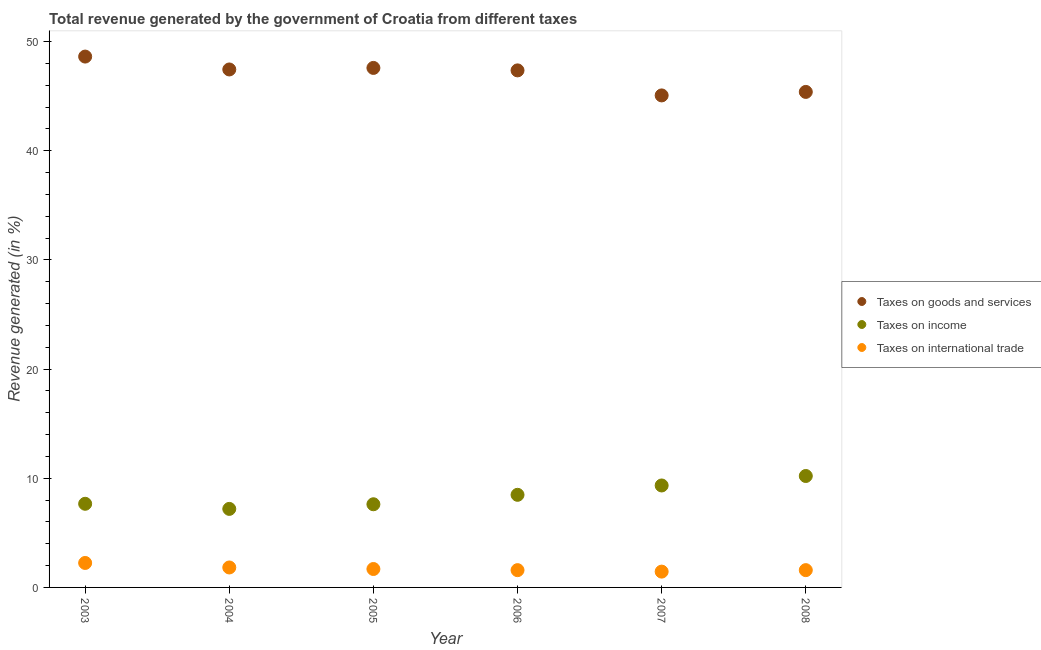How many different coloured dotlines are there?
Your response must be concise. 3. Is the number of dotlines equal to the number of legend labels?
Offer a terse response. Yes. What is the percentage of revenue generated by tax on international trade in 2007?
Keep it short and to the point. 1.45. Across all years, what is the maximum percentage of revenue generated by tax on international trade?
Your response must be concise. 2.24. Across all years, what is the minimum percentage of revenue generated by taxes on income?
Your response must be concise. 7.19. In which year was the percentage of revenue generated by taxes on income maximum?
Ensure brevity in your answer.  2008. What is the total percentage of revenue generated by taxes on goods and services in the graph?
Offer a very short reply. 281.47. What is the difference between the percentage of revenue generated by taxes on income in 2004 and that in 2006?
Give a very brief answer. -1.29. What is the difference between the percentage of revenue generated by taxes on goods and services in 2007 and the percentage of revenue generated by tax on international trade in 2008?
Provide a succinct answer. 43.48. What is the average percentage of revenue generated by taxes on income per year?
Provide a short and direct response. 8.42. In the year 2004, what is the difference between the percentage of revenue generated by tax on international trade and percentage of revenue generated by taxes on income?
Your answer should be compact. -5.37. What is the ratio of the percentage of revenue generated by taxes on income in 2007 to that in 2008?
Make the answer very short. 0.91. Is the difference between the percentage of revenue generated by tax on international trade in 2003 and 2004 greater than the difference between the percentage of revenue generated by taxes on income in 2003 and 2004?
Provide a short and direct response. No. What is the difference between the highest and the second highest percentage of revenue generated by tax on international trade?
Your response must be concise. 0.41. What is the difference between the highest and the lowest percentage of revenue generated by tax on international trade?
Keep it short and to the point. 0.79. In how many years, is the percentage of revenue generated by tax on international trade greater than the average percentage of revenue generated by tax on international trade taken over all years?
Your answer should be compact. 2. Is it the case that in every year, the sum of the percentage of revenue generated by taxes on goods and services and percentage of revenue generated by taxes on income is greater than the percentage of revenue generated by tax on international trade?
Give a very brief answer. Yes. Does the percentage of revenue generated by tax on international trade monotonically increase over the years?
Your answer should be very brief. No. Is the percentage of revenue generated by tax on international trade strictly less than the percentage of revenue generated by taxes on goods and services over the years?
Give a very brief answer. Yes. How many dotlines are there?
Make the answer very short. 3. How many years are there in the graph?
Offer a terse response. 6. What is the title of the graph?
Make the answer very short. Total revenue generated by the government of Croatia from different taxes. What is the label or title of the X-axis?
Provide a succinct answer. Year. What is the label or title of the Y-axis?
Provide a short and direct response. Revenue generated (in %). What is the Revenue generated (in %) in Taxes on goods and services in 2003?
Offer a very short reply. 48.62. What is the Revenue generated (in %) in Taxes on income in 2003?
Provide a short and direct response. 7.66. What is the Revenue generated (in %) in Taxes on international trade in 2003?
Make the answer very short. 2.24. What is the Revenue generated (in %) in Taxes on goods and services in 2004?
Give a very brief answer. 47.44. What is the Revenue generated (in %) of Taxes on income in 2004?
Give a very brief answer. 7.19. What is the Revenue generated (in %) of Taxes on international trade in 2004?
Provide a succinct answer. 1.83. What is the Revenue generated (in %) in Taxes on goods and services in 2005?
Your answer should be compact. 47.59. What is the Revenue generated (in %) in Taxes on income in 2005?
Make the answer very short. 7.62. What is the Revenue generated (in %) in Taxes on international trade in 2005?
Give a very brief answer. 1.69. What is the Revenue generated (in %) in Taxes on goods and services in 2006?
Provide a succinct answer. 47.36. What is the Revenue generated (in %) in Taxes on income in 2006?
Keep it short and to the point. 8.48. What is the Revenue generated (in %) of Taxes on international trade in 2006?
Offer a terse response. 1.58. What is the Revenue generated (in %) in Taxes on goods and services in 2007?
Your response must be concise. 45.07. What is the Revenue generated (in %) of Taxes on income in 2007?
Your response must be concise. 9.34. What is the Revenue generated (in %) of Taxes on international trade in 2007?
Keep it short and to the point. 1.45. What is the Revenue generated (in %) of Taxes on goods and services in 2008?
Provide a short and direct response. 45.39. What is the Revenue generated (in %) in Taxes on income in 2008?
Your response must be concise. 10.21. What is the Revenue generated (in %) in Taxes on international trade in 2008?
Offer a terse response. 1.58. Across all years, what is the maximum Revenue generated (in %) in Taxes on goods and services?
Provide a succinct answer. 48.62. Across all years, what is the maximum Revenue generated (in %) in Taxes on income?
Offer a terse response. 10.21. Across all years, what is the maximum Revenue generated (in %) of Taxes on international trade?
Your answer should be compact. 2.24. Across all years, what is the minimum Revenue generated (in %) in Taxes on goods and services?
Your response must be concise. 45.07. Across all years, what is the minimum Revenue generated (in %) of Taxes on income?
Your answer should be very brief. 7.19. Across all years, what is the minimum Revenue generated (in %) in Taxes on international trade?
Make the answer very short. 1.45. What is the total Revenue generated (in %) in Taxes on goods and services in the graph?
Offer a very short reply. 281.47. What is the total Revenue generated (in %) of Taxes on income in the graph?
Make the answer very short. 50.5. What is the total Revenue generated (in %) in Taxes on international trade in the graph?
Your answer should be very brief. 10.37. What is the difference between the Revenue generated (in %) in Taxes on goods and services in 2003 and that in 2004?
Ensure brevity in your answer.  1.18. What is the difference between the Revenue generated (in %) of Taxes on income in 2003 and that in 2004?
Your answer should be very brief. 0.47. What is the difference between the Revenue generated (in %) in Taxes on international trade in 2003 and that in 2004?
Provide a short and direct response. 0.41. What is the difference between the Revenue generated (in %) in Taxes on goods and services in 2003 and that in 2005?
Offer a very short reply. 1.04. What is the difference between the Revenue generated (in %) in Taxes on income in 2003 and that in 2005?
Your response must be concise. 0.04. What is the difference between the Revenue generated (in %) of Taxes on international trade in 2003 and that in 2005?
Ensure brevity in your answer.  0.55. What is the difference between the Revenue generated (in %) of Taxes on goods and services in 2003 and that in 2006?
Provide a succinct answer. 1.26. What is the difference between the Revenue generated (in %) of Taxes on income in 2003 and that in 2006?
Your answer should be compact. -0.82. What is the difference between the Revenue generated (in %) of Taxes on international trade in 2003 and that in 2006?
Offer a terse response. 0.66. What is the difference between the Revenue generated (in %) of Taxes on goods and services in 2003 and that in 2007?
Offer a very short reply. 3.56. What is the difference between the Revenue generated (in %) of Taxes on income in 2003 and that in 2007?
Make the answer very short. -1.68. What is the difference between the Revenue generated (in %) of Taxes on international trade in 2003 and that in 2007?
Provide a succinct answer. 0.79. What is the difference between the Revenue generated (in %) of Taxes on goods and services in 2003 and that in 2008?
Ensure brevity in your answer.  3.24. What is the difference between the Revenue generated (in %) of Taxes on income in 2003 and that in 2008?
Ensure brevity in your answer.  -2.55. What is the difference between the Revenue generated (in %) in Taxes on international trade in 2003 and that in 2008?
Your response must be concise. 0.66. What is the difference between the Revenue generated (in %) in Taxes on goods and services in 2004 and that in 2005?
Your answer should be compact. -0.14. What is the difference between the Revenue generated (in %) of Taxes on income in 2004 and that in 2005?
Give a very brief answer. -0.42. What is the difference between the Revenue generated (in %) of Taxes on international trade in 2004 and that in 2005?
Offer a terse response. 0.14. What is the difference between the Revenue generated (in %) in Taxes on goods and services in 2004 and that in 2006?
Your answer should be compact. 0.08. What is the difference between the Revenue generated (in %) of Taxes on income in 2004 and that in 2006?
Offer a very short reply. -1.29. What is the difference between the Revenue generated (in %) of Taxes on international trade in 2004 and that in 2006?
Provide a succinct answer. 0.25. What is the difference between the Revenue generated (in %) in Taxes on goods and services in 2004 and that in 2007?
Offer a very short reply. 2.38. What is the difference between the Revenue generated (in %) in Taxes on income in 2004 and that in 2007?
Your answer should be compact. -2.15. What is the difference between the Revenue generated (in %) of Taxes on international trade in 2004 and that in 2007?
Make the answer very short. 0.38. What is the difference between the Revenue generated (in %) in Taxes on goods and services in 2004 and that in 2008?
Your answer should be very brief. 2.06. What is the difference between the Revenue generated (in %) of Taxes on income in 2004 and that in 2008?
Provide a short and direct response. -3.01. What is the difference between the Revenue generated (in %) in Taxes on international trade in 2004 and that in 2008?
Give a very brief answer. 0.24. What is the difference between the Revenue generated (in %) of Taxes on goods and services in 2005 and that in 2006?
Your answer should be compact. 0.23. What is the difference between the Revenue generated (in %) of Taxes on income in 2005 and that in 2006?
Offer a very short reply. -0.87. What is the difference between the Revenue generated (in %) in Taxes on international trade in 2005 and that in 2006?
Offer a terse response. 0.1. What is the difference between the Revenue generated (in %) of Taxes on goods and services in 2005 and that in 2007?
Your answer should be very brief. 2.52. What is the difference between the Revenue generated (in %) in Taxes on income in 2005 and that in 2007?
Your answer should be very brief. -1.72. What is the difference between the Revenue generated (in %) in Taxes on international trade in 2005 and that in 2007?
Make the answer very short. 0.24. What is the difference between the Revenue generated (in %) in Taxes on goods and services in 2005 and that in 2008?
Your answer should be compact. 2.2. What is the difference between the Revenue generated (in %) of Taxes on income in 2005 and that in 2008?
Your response must be concise. -2.59. What is the difference between the Revenue generated (in %) in Taxes on international trade in 2005 and that in 2008?
Provide a short and direct response. 0.1. What is the difference between the Revenue generated (in %) of Taxes on goods and services in 2006 and that in 2007?
Keep it short and to the point. 2.29. What is the difference between the Revenue generated (in %) of Taxes on income in 2006 and that in 2007?
Your response must be concise. -0.86. What is the difference between the Revenue generated (in %) of Taxes on international trade in 2006 and that in 2007?
Keep it short and to the point. 0.13. What is the difference between the Revenue generated (in %) of Taxes on goods and services in 2006 and that in 2008?
Provide a short and direct response. 1.97. What is the difference between the Revenue generated (in %) of Taxes on income in 2006 and that in 2008?
Your answer should be compact. -1.72. What is the difference between the Revenue generated (in %) in Taxes on international trade in 2006 and that in 2008?
Offer a very short reply. -0. What is the difference between the Revenue generated (in %) in Taxes on goods and services in 2007 and that in 2008?
Offer a very short reply. -0.32. What is the difference between the Revenue generated (in %) in Taxes on income in 2007 and that in 2008?
Keep it short and to the point. -0.87. What is the difference between the Revenue generated (in %) in Taxes on international trade in 2007 and that in 2008?
Provide a short and direct response. -0.14. What is the difference between the Revenue generated (in %) in Taxes on goods and services in 2003 and the Revenue generated (in %) in Taxes on income in 2004?
Your answer should be very brief. 41.43. What is the difference between the Revenue generated (in %) of Taxes on goods and services in 2003 and the Revenue generated (in %) of Taxes on international trade in 2004?
Your answer should be compact. 46.8. What is the difference between the Revenue generated (in %) of Taxes on income in 2003 and the Revenue generated (in %) of Taxes on international trade in 2004?
Your answer should be compact. 5.83. What is the difference between the Revenue generated (in %) of Taxes on goods and services in 2003 and the Revenue generated (in %) of Taxes on income in 2005?
Make the answer very short. 41.01. What is the difference between the Revenue generated (in %) of Taxes on goods and services in 2003 and the Revenue generated (in %) of Taxes on international trade in 2005?
Offer a very short reply. 46.94. What is the difference between the Revenue generated (in %) of Taxes on income in 2003 and the Revenue generated (in %) of Taxes on international trade in 2005?
Your response must be concise. 5.97. What is the difference between the Revenue generated (in %) in Taxes on goods and services in 2003 and the Revenue generated (in %) in Taxes on income in 2006?
Make the answer very short. 40.14. What is the difference between the Revenue generated (in %) in Taxes on goods and services in 2003 and the Revenue generated (in %) in Taxes on international trade in 2006?
Your answer should be very brief. 47.04. What is the difference between the Revenue generated (in %) in Taxes on income in 2003 and the Revenue generated (in %) in Taxes on international trade in 2006?
Make the answer very short. 6.08. What is the difference between the Revenue generated (in %) of Taxes on goods and services in 2003 and the Revenue generated (in %) of Taxes on income in 2007?
Make the answer very short. 39.29. What is the difference between the Revenue generated (in %) of Taxes on goods and services in 2003 and the Revenue generated (in %) of Taxes on international trade in 2007?
Make the answer very short. 47.18. What is the difference between the Revenue generated (in %) of Taxes on income in 2003 and the Revenue generated (in %) of Taxes on international trade in 2007?
Offer a very short reply. 6.21. What is the difference between the Revenue generated (in %) of Taxes on goods and services in 2003 and the Revenue generated (in %) of Taxes on income in 2008?
Make the answer very short. 38.42. What is the difference between the Revenue generated (in %) of Taxes on goods and services in 2003 and the Revenue generated (in %) of Taxes on international trade in 2008?
Ensure brevity in your answer.  47.04. What is the difference between the Revenue generated (in %) in Taxes on income in 2003 and the Revenue generated (in %) in Taxes on international trade in 2008?
Give a very brief answer. 6.08. What is the difference between the Revenue generated (in %) in Taxes on goods and services in 2004 and the Revenue generated (in %) in Taxes on income in 2005?
Provide a short and direct response. 39.83. What is the difference between the Revenue generated (in %) in Taxes on goods and services in 2004 and the Revenue generated (in %) in Taxes on international trade in 2005?
Keep it short and to the point. 45.76. What is the difference between the Revenue generated (in %) of Taxes on income in 2004 and the Revenue generated (in %) of Taxes on international trade in 2005?
Offer a very short reply. 5.51. What is the difference between the Revenue generated (in %) in Taxes on goods and services in 2004 and the Revenue generated (in %) in Taxes on income in 2006?
Give a very brief answer. 38.96. What is the difference between the Revenue generated (in %) of Taxes on goods and services in 2004 and the Revenue generated (in %) of Taxes on international trade in 2006?
Offer a very short reply. 45.86. What is the difference between the Revenue generated (in %) in Taxes on income in 2004 and the Revenue generated (in %) in Taxes on international trade in 2006?
Your answer should be very brief. 5.61. What is the difference between the Revenue generated (in %) of Taxes on goods and services in 2004 and the Revenue generated (in %) of Taxes on income in 2007?
Offer a terse response. 38.11. What is the difference between the Revenue generated (in %) in Taxes on goods and services in 2004 and the Revenue generated (in %) in Taxes on international trade in 2007?
Keep it short and to the point. 46. What is the difference between the Revenue generated (in %) of Taxes on income in 2004 and the Revenue generated (in %) of Taxes on international trade in 2007?
Provide a succinct answer. 5.75. What is the difference between the Revenue generated (in %) in Taxes on goods and services in 2004 and the Revenue generated (in %) in Taxes on income in 2008?
Provide a short and direct response. 37.24. What is the difference between the Revenue generated (in %) of Taxes on goods and services in 2004 and the Revenue generated (in %) of Taxes on international trade in 2008?
Ensure brevity in your answer.  45.86. What is the difference between the Revenue generated (in %) of Taxes on income in 2004 and the Revenue generated (in %) of Taxes on international trade in 2008?
Provide a succinct answer. 5.61. What is the difference between the Revenue generated (in %) of Taxes on goods and services in 2005 and the Revenue generated (in %) of Taxes on income in 2006?
Your answer should be compact. 39.1. What is the difference between the Revenue generated (in %) of Taxes on goods and services in 2005 and the Revenue generated (in %) of Taxes on international trade in 2006?
Your answer should be very brief. 46. What is the difference between the Revenue generated (in %) of Taxes on income in 2005 and the Revenue generated (in %) of Taxes on international trade in 2006?
Provide a succinct answer. 6.03. What is the difference between the Revenue generated (in %) of Taxes on goods and services in 2005 and the Revenue generated (in %) of Taxes on income in 2007?
Make the answer very short. 38.25. What is the difference between the Revenue generated (in %) of Taxes on goods and services in 2005 and the Revenue generated (in %) of Taxes on international trade in 2007?
Keep it short and to the point. 46.14. What is the difference between the Revenue generated (in %) of Taxes on income in 2005 and the Revenue generated (in %) of Taxes on international trade in 2007?
Provide a short and direct response. 6.17. What is the difference between the Revenue generated (in %) in Taxes on goods and services in 2005 and the Revenue generated (in %) in Taxes on income in 2008?
Your response must be concise. 37.38. What is the difference between the Revenue generated (in %) in Taxes on goods and services in 2005 and the Revenue generated (in %) in Taxes on international trade in 2008?
Keep it short and to the point. 46. What is the difference between the Revenue generated (in %) in Taxes on income in 2005 and the Revenue generated (in %) in Taxes on international trade in 2008?
Your answer should be compact. 6.03. What is the difference between the Revenue generated (in %) of Taxes on goods and services in 2006 and the Revenue generated (in %) of Taxes on income in 2007?
Provide a succinct answer. 38.02. What is the difference between the Revenue generated (in %) in Taxes on goods and services in 2006 and the Revenue generated (in %) in Taxes on international trade in 2007?
Provide a short and direct response. 45.91. What is the difference between the Revenue generated (in %) of Taxes on income in 2006 and the Revenue generated (in %) of Taxes on international trade in 2007?
Your answer should be compact. 7.03. What is the difference between the Revenue generated (in %) of Taxes on goods and services in 2006 and the Revenue generated (in %) of Taxes on income in 2008?
Your response must be concise. 37.15. What is the difference between the Revenue generated (in %) in Taxes on goods and services in 2006 and the Revenue generated (in %) in Taxes on international trade in 2008?
Your answer should be very brief. 45.78. What is the difference between the Revenue generated (in %) in Taxes on income in 2006 and the Revenue generated (in %) in Taxes on international trade in 2008?
Your answer should be very brief. 6.9. What is the difference between the Revenue generated (in %) in Taxes on goods and services in 2007 and the Revenue generated (in %) in Taxes on income in 2008?
Your answer should be compact. 34.86. What is the difference between the Revenue generated (in %) in Taxes on goods and services in 2007 and the Revenue generated (in %) in Taxes on international trade in 2008?
Make the answer very short. 43.48. What is the difference between the Revenue generated (in %) in Taxes on income in 2007 and the Revenue generated (in %) in Taxes on international trade in 2008?
Provide a short and direct response. 7.76. What is the average Revenue generated (in %) in Taxes on goods and services per year?
Offer a terse response. 46.91. What is the average Revenue generated (in %) in Taxes on income per year?
Keep it short and to the point. 8.42. What is the average Revenue generated (in %) in Taxes on international trade per year?
Make the answer very short. 1.73. In the year 2003, what is the difference between the Revenue generated (in %) of Taxes on goods and services and Revenue generated (in %) of Taxes on income?
Provide a short and direct response. 40.96. In the year 2003, what is the difference between the Revenue generated (in %) in Taxes on goods and services and Revenue generated (in %) in Taxes on international trade?
Offer a very short reply. 46.38. In the year 2003, what is the difference between the Revenue generated (in %) of Taxes on income and Revenue generated (in %) of Taxes on international trade?
Offer a terse response. 5.42. In the year 2004, what is the difference between the Revenue generated (in %) in Taxes on goods and services and Revenue generated (in %) in Taxes on income?
Offer a very short reply. 40.25. In the year 2004, what is the difference between the Revenue generated (in %) in Taxes on goods and services and Revenue generated (in %) in Taxes on international trade?
Your answer should be compact. 45.62. In the year 2004, what is the difference between the Revenue generated (in %) of Taxes on income and Revenue generated (in %) of Taxes on international trade?
Ensure brevity in your answer.  5.37. In the year 2005, what is the difference between the Revenue generated (in %) of Taxes on goods and services and Revenue generated (in %) of Taxes on income?
Provide a short and direct response. 39.97. In the year 2005, what is the difference between the Revenue generated (in %) in Taxes on goods and services and Revenue generated (in %) in Taxes on international trade?
Give a very brief answer. 45.9. In the year 2005, what is the difference between the Revenue generated (in %) in Taxes on income and Revenue generated (in %) in Taxes on international trade?
Your answer should be very brief. 5.93. In the year 2006, what is the difference between the Revenue generated (in %) of Taxes on goods and services and Revenue generated (in %) of Taxes on income?
Give a very brief answer. 38.88. In the year 2006, what is the difference between the Revenue generated (in %) of Taxes on goods and services and Revenue generated (in %) of Taxes on international trade?
Make the answer very short. 45.78. In the year 2006, what is the difference between the Revenue generated (in %) in Taxes on income and Revenue generated (in %) in Taxes on international trade?
Give a very brief answer. 6.9. In the year 2007, what is the difference between the Revenue generated (in %) of Taxes on goods and services and Revenue generated (in %) of Taxes on income?
Provide a succinct answer. 35.73. In the year 2007, what is the difference between the Revenue generated (in %) of Taxes on goods and services and Revenue generated (in %) of Taxes on international trade?
Offer a very short reply. 43.62. In the year 2007, what is the difference between the Revenue generated (in %) in Taxes on income and Revenue generated (in %) in Taxes on international trade?
Offer a terse response. 7.89. In the year 2008, what is the difference between the Revenue generated (in %) in Taxes on goods and services and Revenue generated (in %) in Taxes on income?
Offer a very short reply. 35.18. In the year 2008, what is the difference between the Revenue generated (in %) in Taxes on goods and services and Revenue generated (in %) in Taxes on international trade?
Provide a succinct answer. 43.8. In the year 2008, what is the difference between the Revenue generated (in %) in Taxes on income and Revenue generated (in %) in Taxes on international trade?
Your response must be concise. 8.62. What is the ratio of the Revenue generated (in %) in Taxes on goods and services in 2003 to that in 2004?
Keep it short and to the point. 1.02. What is the ratio of the Revenue generated (in %) in Taxes on income in 2003 to that in 2004?
Offer a terse response. 1.06. What is the ratio of the Revenue generated (in %) in Taxes on international trade in 2003 to that in 2004?
Provide a succinct answer. 1.23. What is the ratio of the Revenue generated (in %) in Taxes on goods and services in 2003 to that in 2005?
Ensure brevity in your answer.  1.02. What is the ratio of the Revenue generated (in %) of Taxes on income in 2003 to that in 2005?
Your response must be concise. 1.01. What is the ratio of the Revenue generated (in %) in Taxes on international trade in 2003 to that in 2005?
Keep it short and to the point. 1.33. What is the ratio of the Revenue generated (in %) of Taxes on goods and services in 2003 to that in 2006?
Offer a very short reply. 1.03. What is the ratio of the Revenue generated (in %) of Taxes on income in 2003 to that in 2006?
Offer a terse response. 0.9. What is the ratio of the Revenue generated (in %) in Taxes on international trade in 2003 to that in 2006?
Ensure brevity in your answer.  1.42. What is the ratio of the Revenue generated (in %) of Taxes on goods and services in 2003 to that in 2007?
Provide a short and direct response. 1.08. What is the ratio of the Revenue generated (in %) in Taxes on income in 2003 to that in 2007?
Your answer should be very brief. 0.82. What is the ratio of the Revenue generated (in %) in Taxes on international trade in 2003 to that in 2007?
Your answer should be very brief. 1.55. What is the ratio of the Revenue generated (in %) of Taxes on goods and services in 2003 to that in 2008?
Your answer should be compact. 1.07. What is the ratio of the Revenue generated (in %) of Taxes on income in 2003 to that in 2008?
Keep it short and to the point. 0.75. What is the ratio of the Revenue generated (in %) in Taxes on international trade in 2003 to that in 2008?
Keep it short and to the point. 1.42. What is the ratio of the Revenue generated (in %) in Taxes on goods and services in 2004 to that in 2005?
Keep it short and to the point. 1. What is the ratio of the Revenue generated (in %) in Taxes on income in 2004 to that in 2005?
Keep it short and to the point. 0.94. What is the ratio of the Revenue generated (in %) of Taxes on international trade in 2004 to that in 2005?
Your response must be concise. 1.08. What is the ratio of the Revenue generated (in %) in Taxes on income in 2004 to that in 2006?
Offer a very short reply. 0.85. What is the ratio of the Revenue generated (in %) of Taxes on international trade in 2004 to that in 2006?
Offer a very short reply. 1.15. What is the ratio of the Revenue generated (in %) in Taxes on goods and services in 2004 to that in 2007?
Your answer should be compact. 1.05. What is the ratio of the Revenue generated (in %) of Taxes on income in 2004 to that in 2007?
Provide a short and direct response. 0.77. What is the ratio of the Revenue generated (in %) in Taxes on international trade in 2004 to that in 2007?
Your answer should be very brief. 1.26. What is the ratio of the Revenue generated (in %) in Taxes on goods and services in 2004 to that in 2008?
Ensure brevity in your answer.  1.05. What is the ratio of the Revenue generated (in %) in Taxes on income in 2004 to that in 2008?
Offer a terse response. 0.7. What is the ratio of the Revenue generated (in %) of Taxes on international trade in 2004 to that in 2008?
Offer a terse response. 1.15. What is the ratio of the Revenue generated (in %) in Taxes on goods and services in 2005 to that in 2006?
Your response must be concise. 1. What is the ratio of the Revenue generated (in %) in Taxes on income in 2005 to that in 2006?
Keep it short and to the point. 0.9. What is the ratio of the Revenue generated (in %) in Taxes on international trade in 2005 to that in 2006?
Your response must be concise. 1.07. What is the ratio of the Revenue generated (in %) in Taxes on goods and services in 2005 to that in 2007?
Keep it short and to the point. 1.06. What is the ratio of the Revenue generated (in %) in Taxes on income in 2005 to that in 2007?
Offer a terse response. 0.82. What is the ratio of the Revenue generated (in %) in Taxes on international trade in 2005 to that in 2007?
Offer a terse response. 1.17. What is the ratio of the Revenue generated (in %) of Taxes on goods and services in 2005 to that in 2008?
Your response must be concise. 1.05. What is the ratio of the Revenue generated (in %) in Taxes on income in 2005 to that in 2008?
Give a very brief answer. 0.75. What is the ratio of the Revenue generated (in %) in Taxes on international trade in 2005 to that in 2008?
Give a very brief answer. 1.07. What is the ratio of the Revenue generated (in %) in Taxes on goods and services in 2006 to that in 2007?
Ensure brevity in your answer.  1.05. What is the ratio of the Revenue generated (in %) in Taxes on income in 2006 to that in 2007?
Ensure brevity in your answer.  0.91. What is the ratio of the Revenue generated (in %) of Taxes on international trade in 2006 to that in 2007?
Make the answer very short. 1.09. What is the ratio of the Revenue generated (in %) in Taxes on goods and services in 2006 to that in 2008?
Your answer should be compact. 1.04. What is the ratio of the Revenue generated (in %) of Taxes on income in 2006 to that in 2008?
Ensure brevity in your answer.  0.83. What is the ratio of the Revenue generated (in %) in Taxes on goods and services in 2007 to that in 2008?
Provide a succinct answer. 0.99. What is the ratio of the Revenue generated (in %) of Taxes on income in 2007 to that in 2008?
Make the answer very short. 0.92. What is the ratio of the Revenue generated (in %) of Taxes on international trade in 2007 to that in 2008?
Offer a very short reply. 0.91. What is the difference between the highest and the second highest Revenue generated (in %) of Taxes on goods and services?
Give a very brief answer. 1.04. What is the difference between the highest and the second highest Revenue generated (in %) in Taxes on income?
Provide a succinct answer. 0.87. What is the difference between the highest and the second highest Revenue generated (in %) in Taxes on international trade?
Provide a succinct answer. 0.41. What is the difference between the highest and the lowest Revenue generated (in %) in Taxes on goods and services?
Your answer should be compact. 3.56. What is the difference between the highest and the lowest Revenue generated (in %) in Taxes on income?
Your answer should be very brief. 3.01. What is the difference between the highest and the lowest Revenue generated (in %) of Taxes on international trade?
Your answer should be compact. 0.79. 